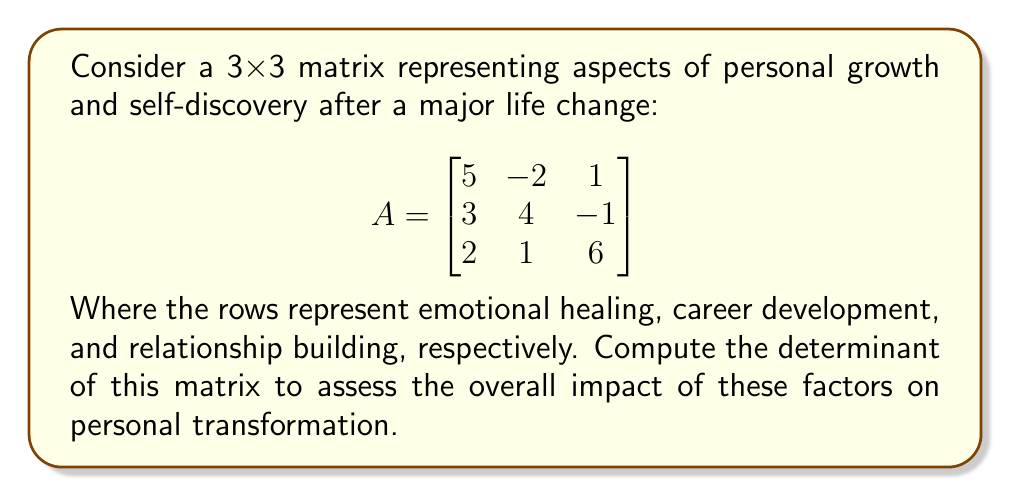Can you answer this question? To compute the determinant of a 3x3 matrix, we can use the Laplace expansion along the first row:

$$\det(A) = a_{11}M_{11} - a_{12}M_{12} + a_{13}M_{13}$$

Where $M_{ij}$ is the minor of the element $a_{ij}$, obtained by removing the i-th row and j-th column and calculating the determinant of the resulting 2x2 matrix.

For our matrix A:

1) $M_{11} = \det\begin{bmatrix}4 & -1 \\ 1 & 6\end{bmatrix} = 4(6) - (-1)(1) = 25$

2) $M_{12} = \det\begin{bmatrix}3 & -1 \\ 2 & 6\end{bmatrix} = 3(6) - (-1)(2) = 20$

3) $M_{13} = \det\begin{bmatrix}3 & 4 \\ 2 & 1\end{bmatrix} = 3(1) - 4(2) = -5$

Now, we can apply the Laplace expansion:

$$\det(A) = 5(25) - (-2)(20) + 1(-5)$$
$$\det(A) = 125 + 40 - 5$$
$$\det(A) = 160$$

The positive determinant indicates that these aspects of personal growth are working together to create a significant positive transformation.
Answer: $\det(A) = 160$ 